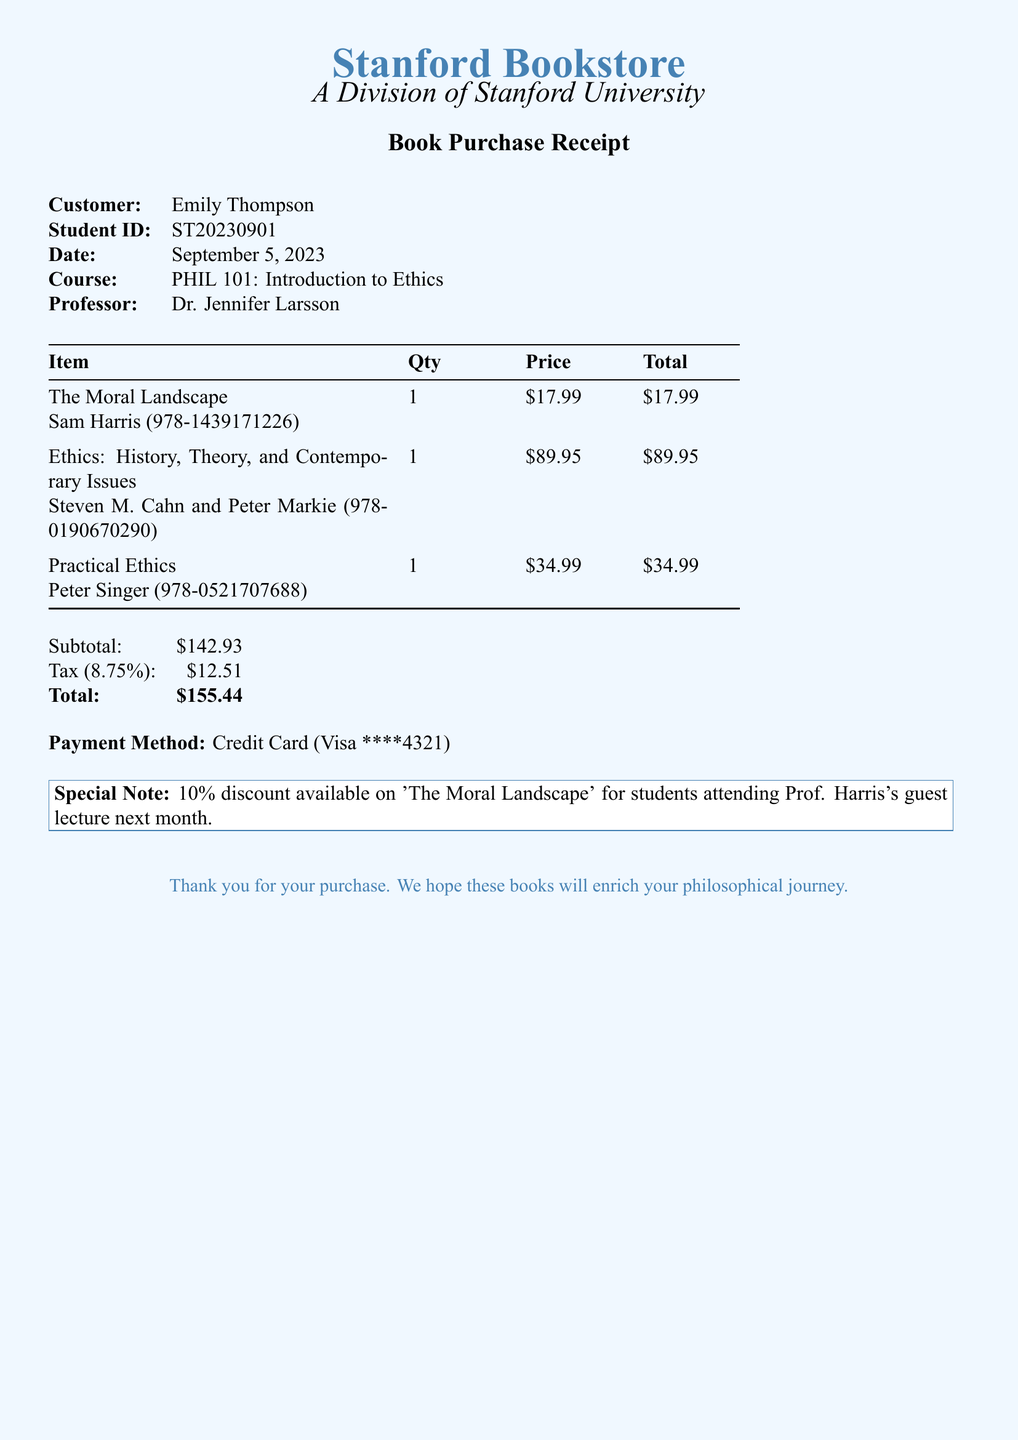What is the date of the purchase? The date of the purchase is provided in the receipt section of the document.
Answer: September 5, 2023 Who is the professor for PHIL 101? The professor's name is specified in the customer information section of the document.
Answer: Dr. Jennifer Larsson What is the price of "The Moral Landscape"? The price of "The Moral Landscape" is listed under the item details in the document.
Answer: $17.99 What is the subtotal amount before tax? The subtotal is detailed in the final calculations section of the document.
Answer: $142.93 How much tax is applied on the bill? The amount of tax is shown in the calculations section, following the subtotal.
Answer: $12.51 What is the total amount paid? The total amount is listed at the end of the document, combining subtotal and tax.
Answer: $155.44 What payment method was used? The payment method is indicated in the payment information section of the document.
Answer: Credit Card (Visa ****4321) What discount is available for "The Moral Landscape"? The document includes a special note mentioning the discount available for students.
Answer: 10% discount How many philosophy textbooks were purchased? The quantity of textbooks can be inferred from the list of items on the receipt.
Answer: 3 